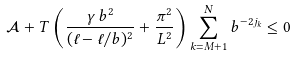Convert formula to latex. <formula><loc_0><loc_0><loc_500><loc_500>\mathcal { A } + T \left ( \frac { \gamma \, b ^ { 2 } } { ( \ell - \ell / b ) ^ { 2 } } + \frac { \pi ^ { 2 } } { L ^ { 2 } } \right ) \sum _ { k = M + 1 } ^ { N } b ^ { - 2 j _ { k } } \leq 0</formula> 